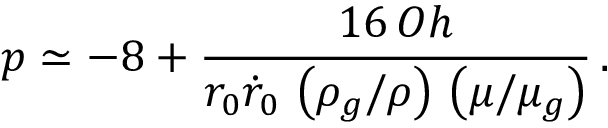Convert formula to latex. <formula><loc_0><loc_0><loc_500><loc_500>p \simeq - 8 + \frac { 1 6 \, O h } { r _ { 0 } \dot { r } _ { 0 } \, \left ( \rho _ { g } / \rho \right ) \, \left ( \mu / \mu _ { g } \right ) } \, .</formula> 